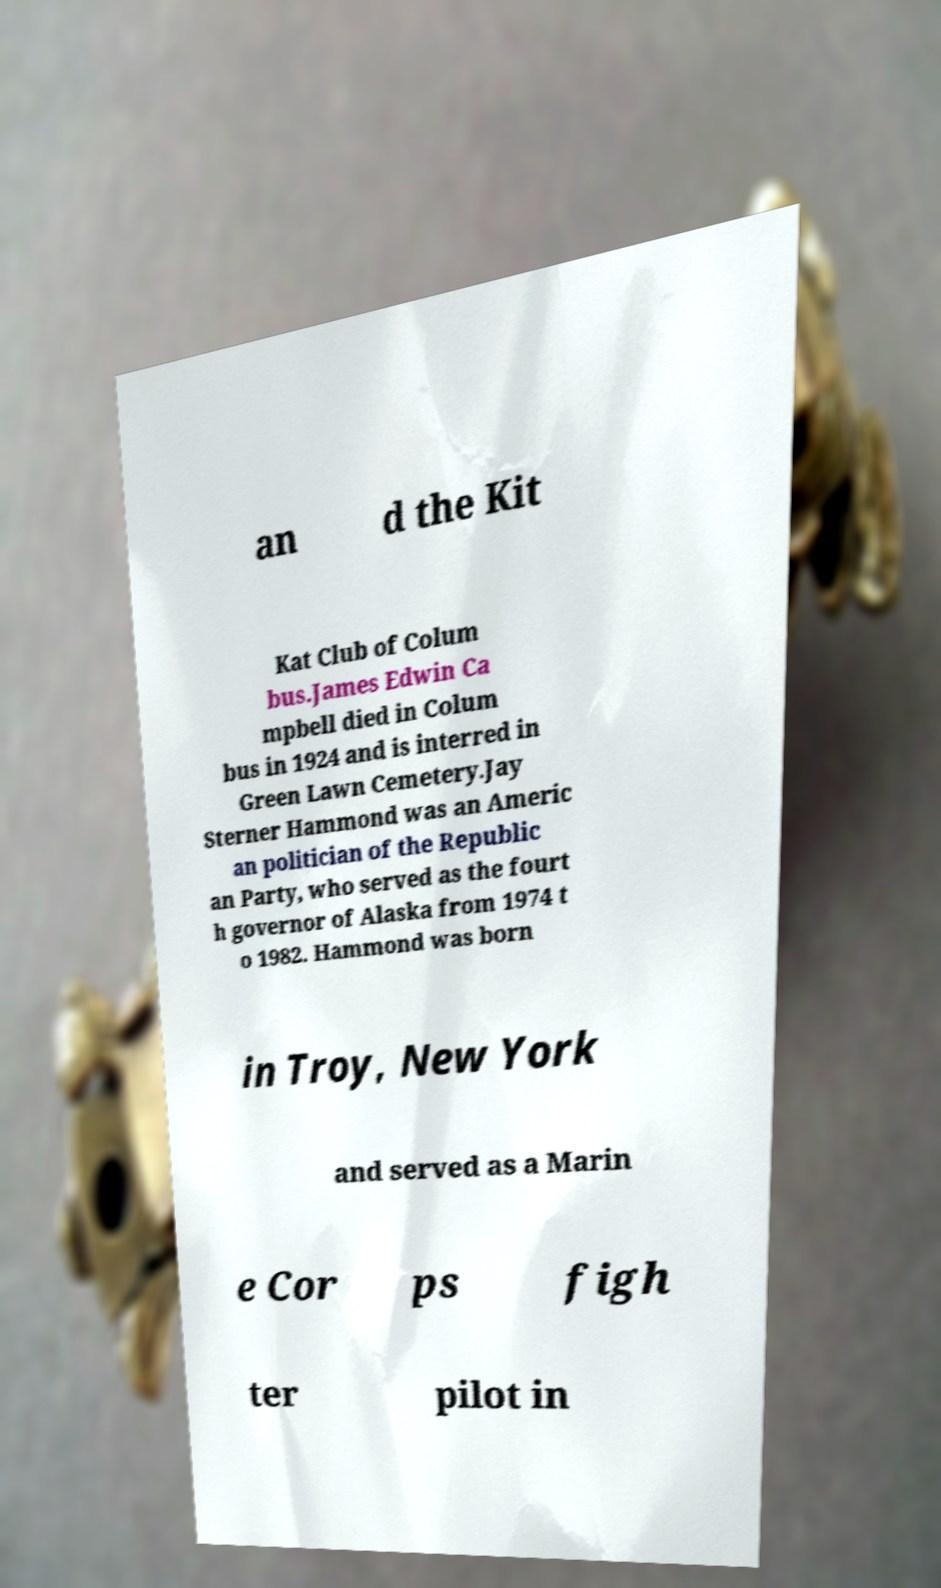Can you accurately transcribe the text from the provided image for me? an d the Kit Kat Club of Colum bus.James Edwin Ca mpbell died in Colum bus in 1924 and is interred in Green Lawn Cemetery.Jay Sterner Hammond was an Americ an politician of the Republic an Party, who served as the fourt h governor of Alaska from 1974 t o 1982. Hammond was born in Troy, New York and served as a Marin e Cor ps figh ter pilot in 